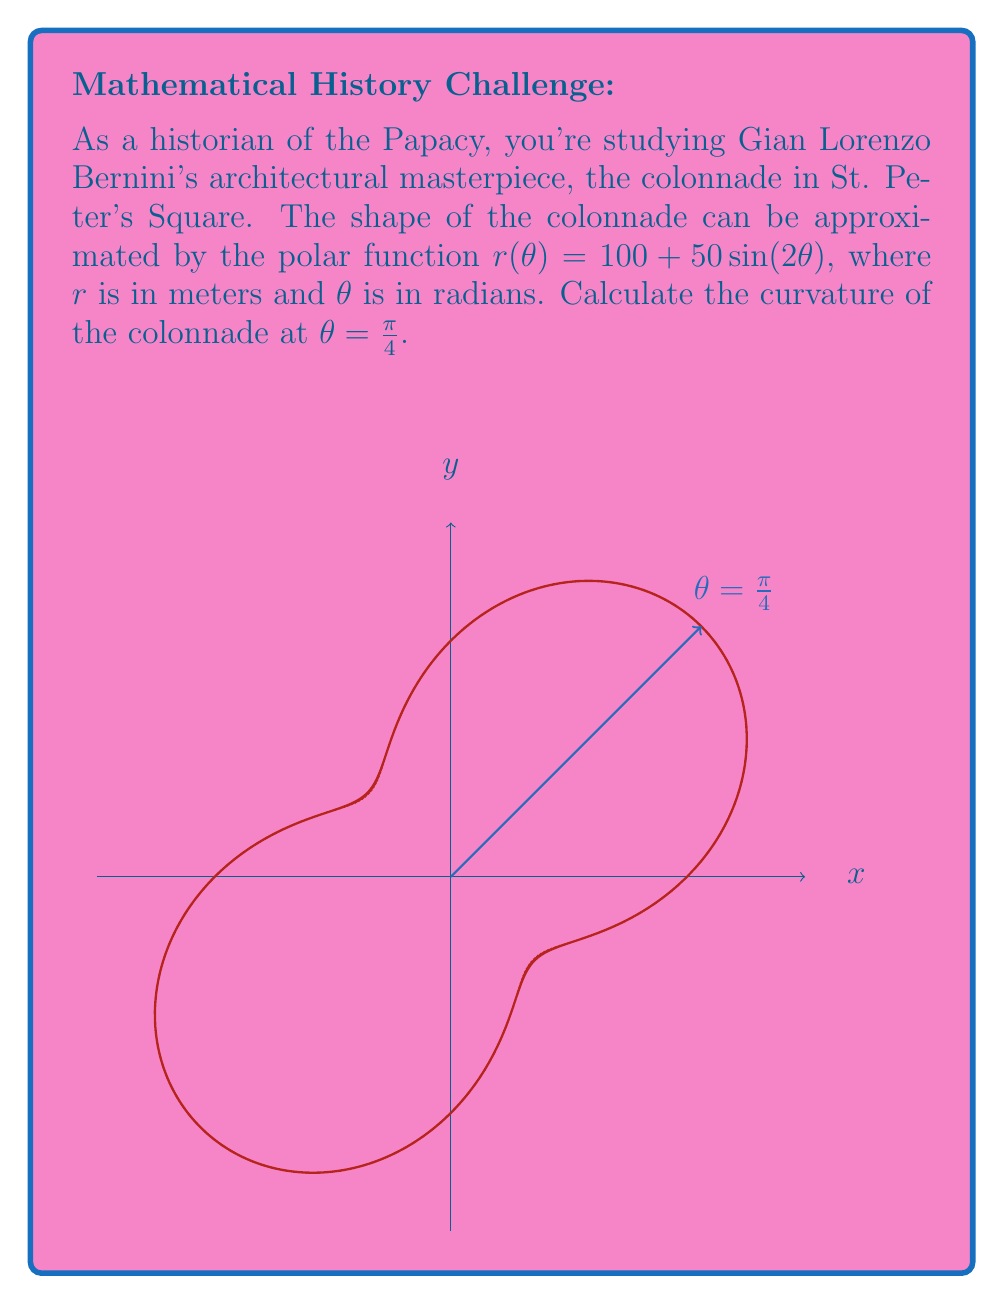Could you help me with this problem? To calculate the curvature of a polar curve, we'll use the formula:

$$\kappa = \frac{|r^2 + 2(r')^2 - rr''|}{(r^2 + (r')^2)^{3/2}}$$

where $r = r(\theta)$, $r' = \frac{dr}{d\theta}$, and $r'' = \frac{d^2r}{d\theta^2}$.

Step 1: Find $r$, $r'$, and $r''$
$r(\theta) = 100 + 50\sin(2\theta)$
$r'(\theta) = 100\cos(2\theta)$
$r''(\theta) = -200\sin(2\theta)$

Step 2: Evaluate at $\theta = \frac{\pi}{4}$
$r(\frac{\pi}{4}) = 100 + 50\sin(\frac{\pi}{2}) = 150$
$r'(\frac{\pi}{4}) = 100\cos(\frac{\pi}{2}) = 0$
$r''(\frac{\pi}{4}) = -200\sin(\frac{\pi}{2}) = -200$

Step 3: Substitute into the curvature formula
$$\kappa = \frac{|150^2 + 2(0)^2 - 150(-200)|}{(150^2 + 0^2)^{3/2}}$$

Step 4: Simplify
$$\kappa = \frac{|22500 + 30000|}{(22500)^{3/2}} = \frac{52500}{(22500)^{3/2}}$$

Step 5: Calculate the final result
$$\kappa \approx 0.0156 \text{ m}^{-1}$$
Answer: $\kappa \approx 0.0156 \text{ m}^{-1}$ 